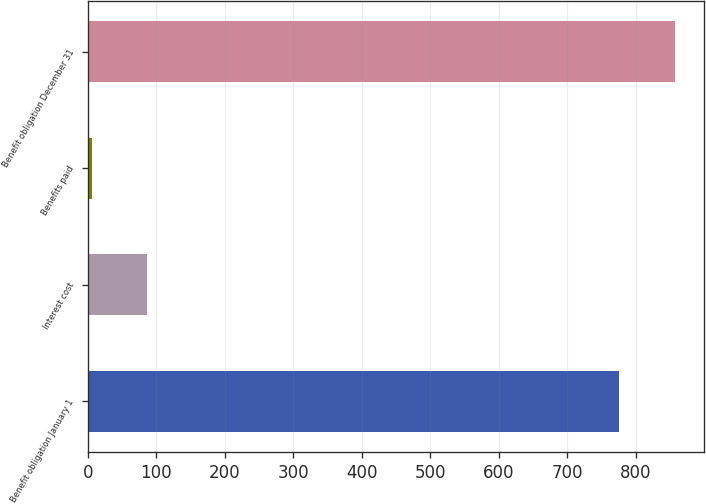Convert chart. <chart><loc_0><loc_0><loc_500><loc_500><bar_chart><fcel>Benefit obligation January 1<fcel>Interest cost<fcel>Benefits paid<fcel>Benefit obligation December 31<nl><fcel>776<fcel>86.6<fcel>6<fcel>856.6<nl></chart> 